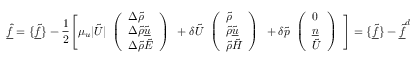<formula> <loc_0><loc_0><loc_500><loc_500>\underline { { \hat { f } } } = \{ \underline { { \tilde { f } } } \} - \frac { 1 } { 2 } \left [ \mu _ { u } | \tilde { U } | \begin{array} { l } { \left ( \begin{array} { l } { \Delta \tilde { \rho } } \\ { \Delta \tilde { \rho } \tilde { \underline { u } } } \\ { \Delta \tilde { \rho } \tilde { E } } \end{array} \right ) } \end{array} + \delta \tilde { U } \begin{array} { l } { \left ( \begin{array} { l } { \tilde { \rho } } \\ { \tilde { \rho } \tilde { \underline { u } } } \\ { \tilde { \rho } \tilde { H } } \end{array} \right ) } \end{array} + \delta \tilde { p } \begin{array} { l } { \left ( \begin{array} { l } { 0 } \\ { \underline { n } } \\ { \tilde { U } } \end{array} \right ) } \end{array} \right ] = \{ \underline { { \tilde { f } } } \} - \underline { { \tilde { f } } } ^ { d }</formula> 